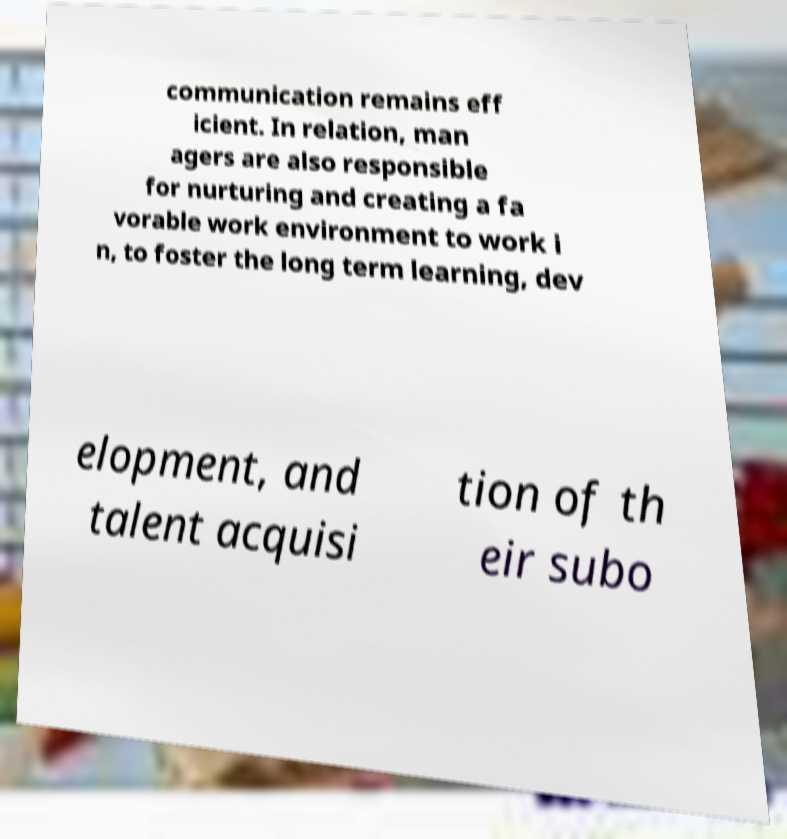Please identify and transcribe the text found in this image. communication remains eff icient. In relation, man agers are also responsible for nurturing and creating a fa vorable work environment to work i n, to foster the long term learning, dev elopment, and talent acquisi tion of th eir subo 